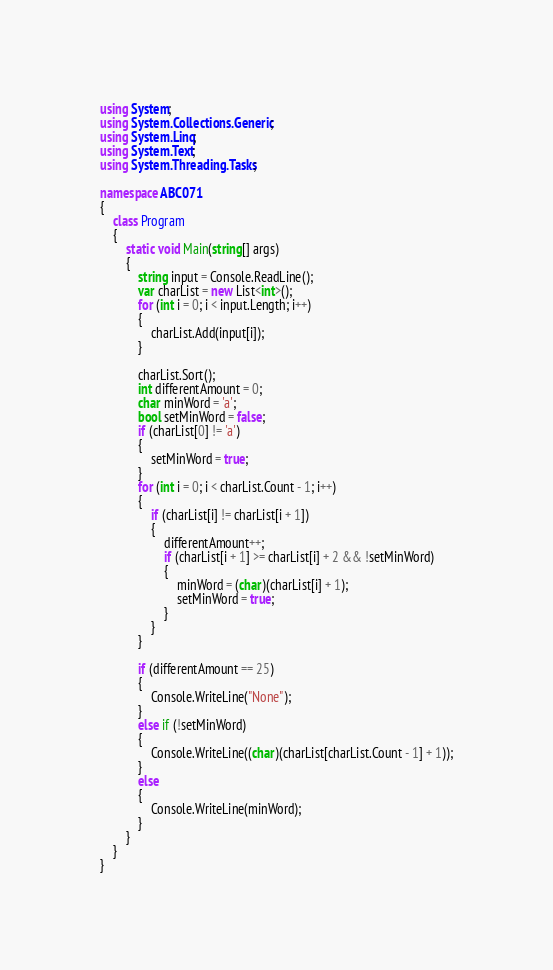<code> <loc_0><loc_0><loc_500><loc_500><_C#_>using System;
using System.Collections.Generic;
using System.Linq;
using System.Text;
using System.Threading.Tasks;

namespace ABC071
{
    class Program
    {
        static void Main(string[] args)
        {
            string input = Console.ReadLine();
            var charList = new List<int>();
            for (int i = 0; i < input.Length; i++)
            {
                charList.Add(input[i]);
            }

            charList.Sort();
            int differentAmount = 0;
            char minWord = 'a';
            bool setMinWord = false;
            if (charList[0] != 'a')
            {
                setMinWord = true;
            }
            for (int i = 0; i < charList.Count - 1; i++)
            {
                if (charList[i] != charList[i + 1])
                {
                    differentAmount++;
                    if (charList[i + 1] >= charList[i] + 2 && !setMinWord)
                    {
                        minWord = (char)(charList[i] + 1);
                        setMinWord = true;
                    }
                }
            }

            if (differentAmount == 25)
            {
                Console.WriteLine("None");
            }
            else if (!setMinWord)
            {
                Console.WriteLine((char)(charList[charList.Count - 1] + 1));
            }
            else
            {
                Console.WriteLine(minWord);
            }
        }
    }
}</code> 